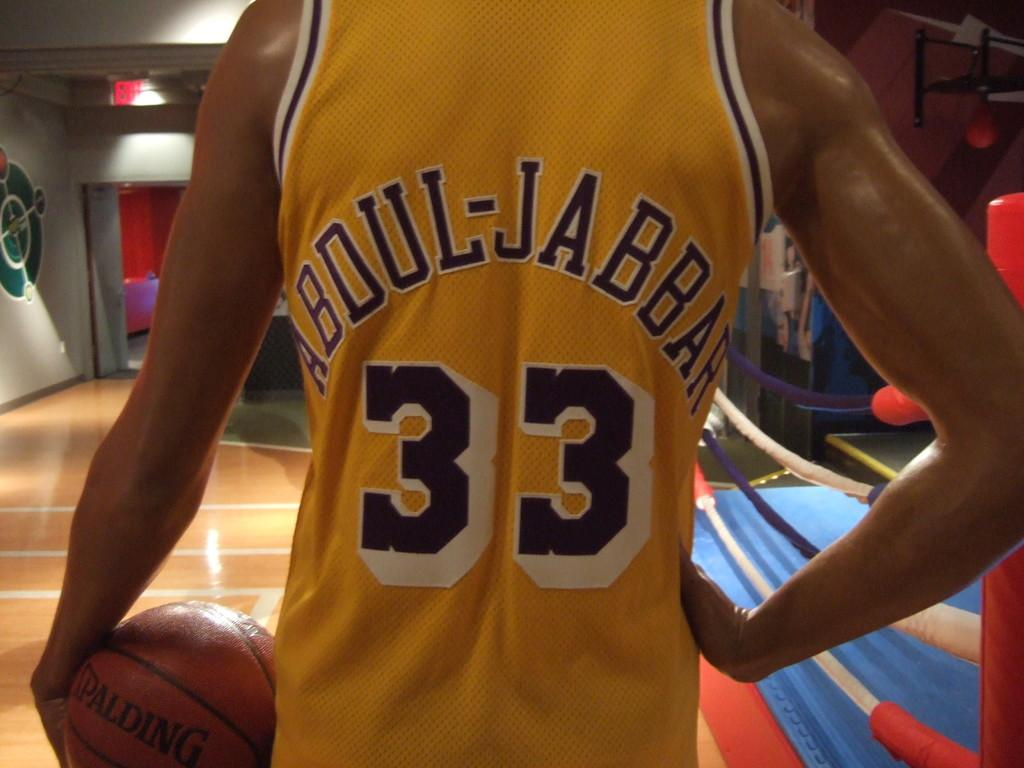Provide a one-sentence caption for the provided image. A basketball member wearing a yellow jersey that says Abdul-Jabbar 33 on the back standing with a basketball in his left hand and his right hand on his hip. 